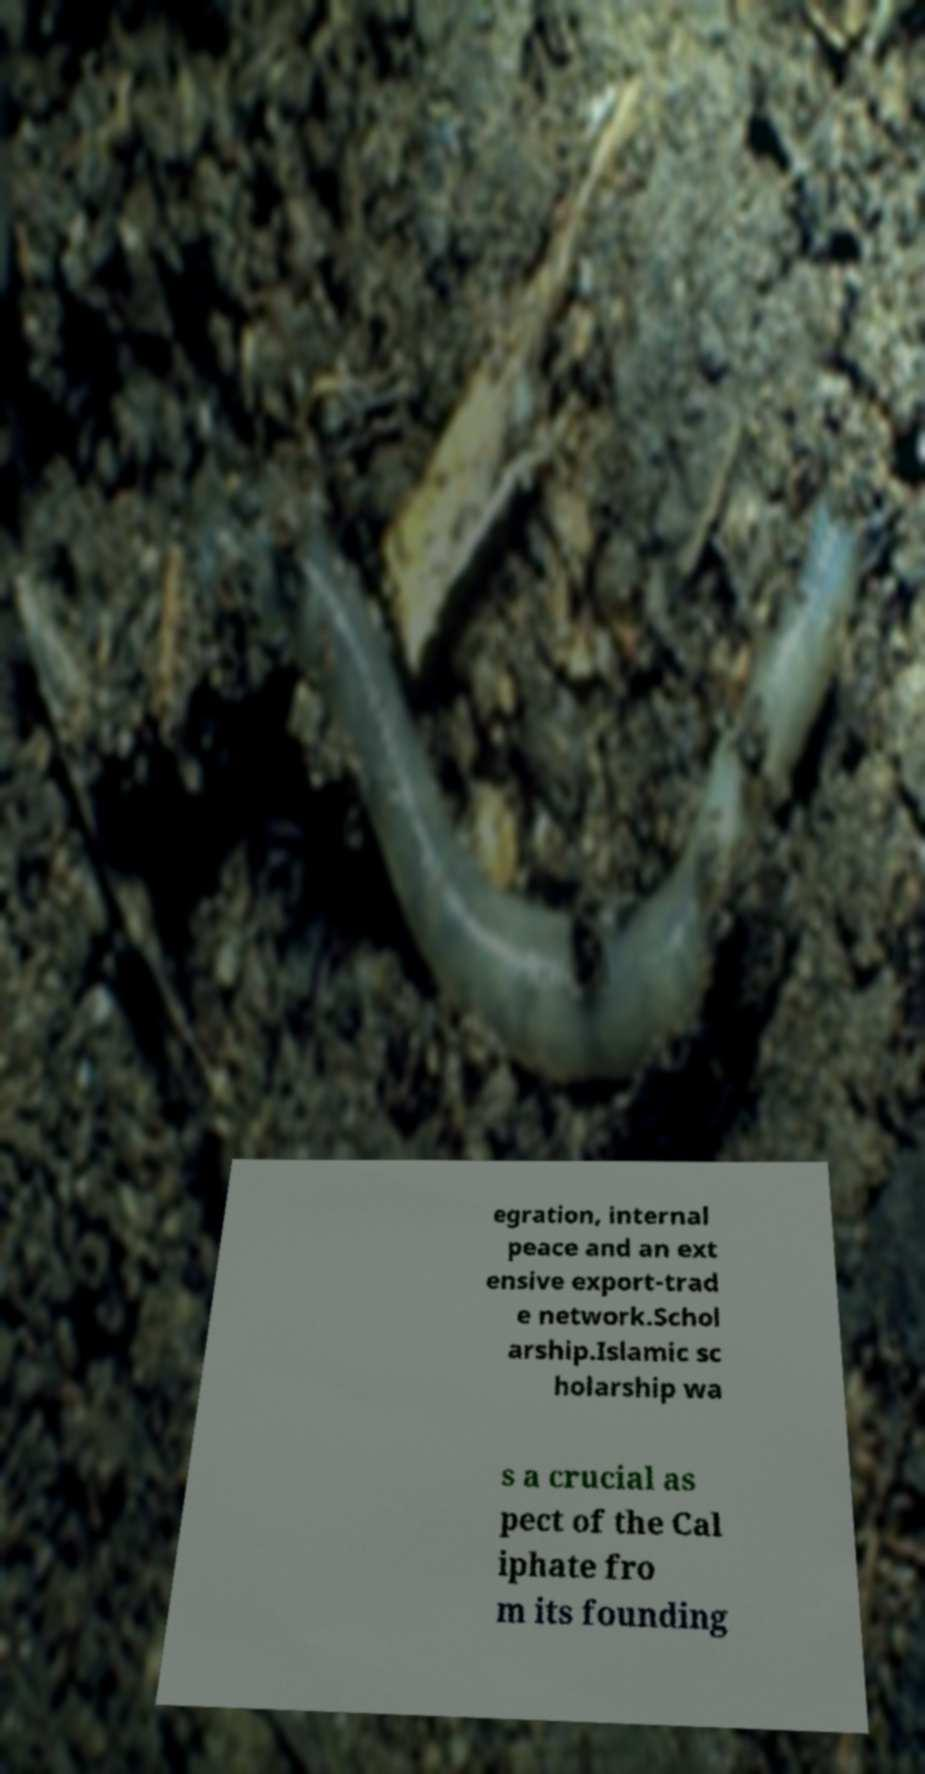Please identify and transcribe the text found in this image. egration, internal peace and an ext ensive export-trad e network.Schol arship.Islamic sc holarship wa s a crucial as pect of the Cal iphate fro m its founding 